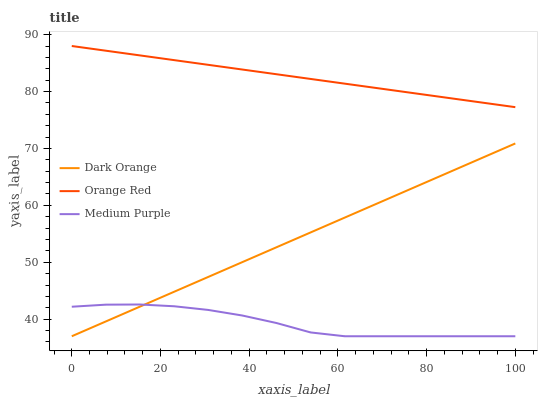Does Medium Purple have the minimum area under the curve?
Answer yes or no. Yes. Does Orange Red have the maximum area under the curve?
Answer yes or no. Yes. Does Dark Orange have the minimum area under the curve?
Answer yes or no. No. Does Dark Orange have the maximum area under the curve?
Answer yes or no. No. Is Dark Orange the smoothest?
Answer yes or no. Yes. Is Medium Purple the roughest?
Answer yes or no. Yes. Is Orange Red the smoothest?
Answer yes or no. No. Is Orange Red the roughest?
Answer yes or no. No. Does Orange Red have the lowest value?
Answer yes or no. No. Does Dark Orange have the highest value?
Answer yes or no. No. Is Dark Orange less than Orange Red?
Answer yes or no. Yes. Is Orange Red greater than Medium Purple?
Answer yes or no. Yes. Does Dark Orange intersect Orange Red?
Answer yes or no. No. 